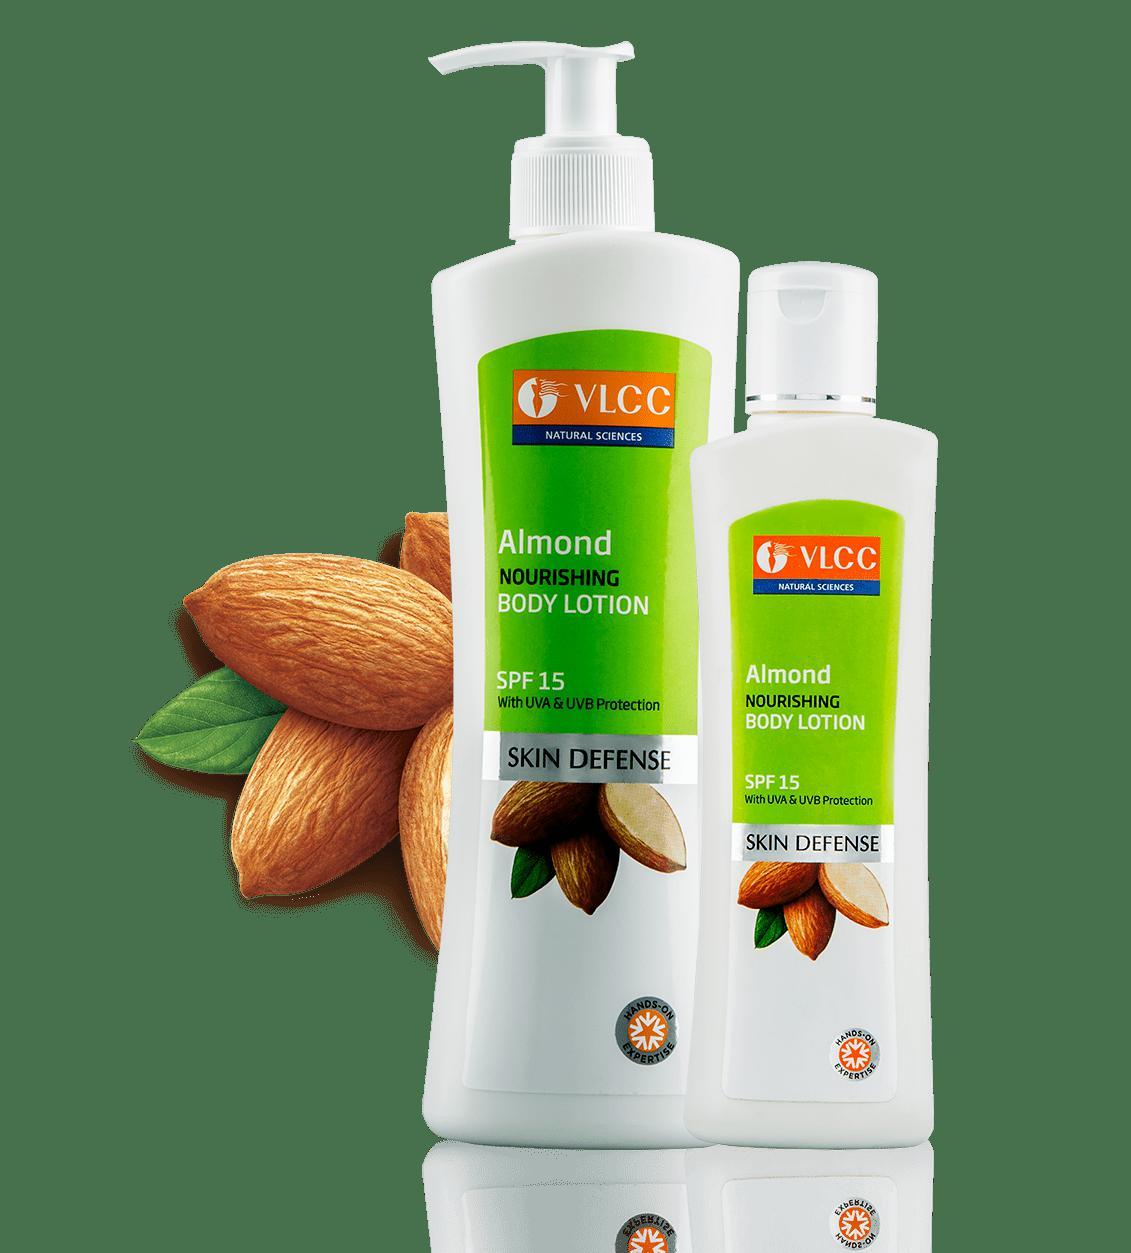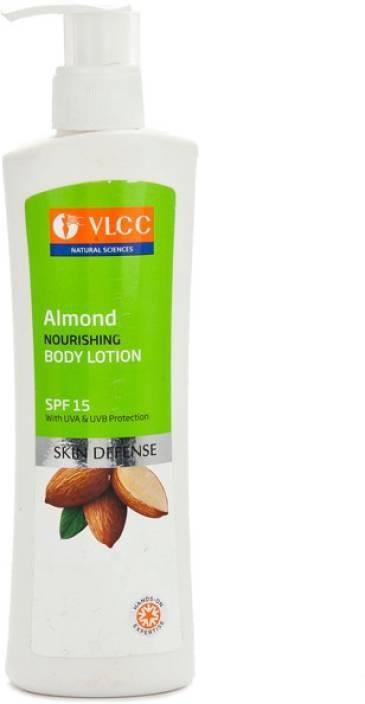The first image is the image on the left, the second image is the image on the right. Analyze the images presented: Is the assertion "An image features two unwrapped pump bottles with nozzles turned rightward." valid? Answer yes or no. No. The first image is the image on the left, the second image is the image on the right. Analyze the images presented: Is the assertion "There are two dispensers pointing right in one of the images." valid? Answer yes or no. No. 